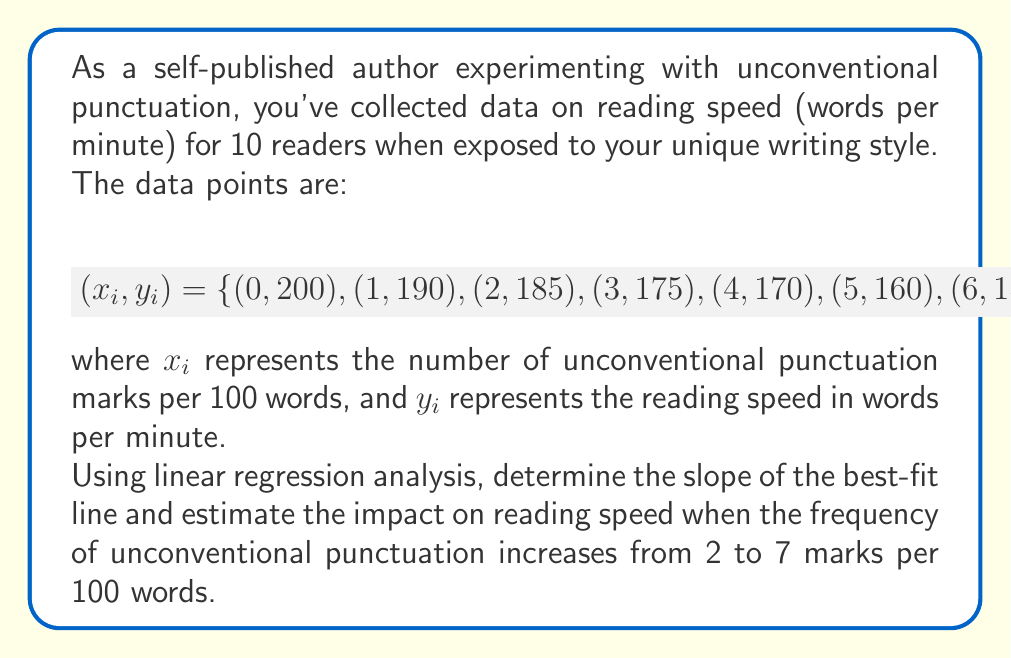Help me with this question. To solve this problem, we'll use linear regression analysis. The steps are as follows:

1) First, we need to calculate the slope of the best-fit line using the formula:

   $$m = \frac{n\sum_{i=1}^n x_iy_i - \sum_{i=1}^n x_i \sum_{i=1}^n y_i}{n\sum_{i=1}^n x_i^2 - (\sum_{i=1}^n x_i)^2}$$

2) Calculate the necessary sums:
   $n = 10$
   $\sum x_i = 0 + 1 + 2 + 3 + 4 + 5 + 6 + 7 + 8 + 9 = 45$
   $\sum y_i = 200 + 190 + 185 + 175 + 170 + 160 + 155 + 150 + 140 + 135 = 1660$
   $\sum x_i^2 = 0^2 + 1^2 + 2^2 + 3^2 + 4^2 + 5^2 + 6^2 + 7^2 + 8^2 + 9^2 = 285$
   $\sum x_iy_i = 0(200) + 1(190) + 2(185) + 3(175) + 4(170) + 5(160) + 6(155) + 7(150) + 8(140) + 9(135) = 6415$

3) Substitute these values into the slope formula:

   $$m = \frac{10(6415) - 45(1660)}{10(285) - 45^2} = \frac{64150 - 74700}{2850 - 2025} = \frac{-10550}{825} = -7.33333$$

4) The slope is approximately -7.33333, meaning that for each additional unconventional punctuation mark per 100 words, the reading speed decreases by about 7.33333 words per minute.

5) To estimate the impact when the frequency increases from 2 to 7 marks per 100 words, we multiply the change in x (5) by the slope:

   $$\text{Impact} = 5 \times (-7.33333) = -36.66667$$

This means the reading speed is estimated to decrease by approximately 36.67 words per minute when the frequency of unconventional punctuation increases from 2 to 7 marks per 100 words.
Answer: The slope of the best-fit line is approximately -7.33333 words per minute per unconventional punctuation mark. The estimated impact on reading speed when increasing from 2 to 7 unconventional punctuation marks per 100 words is a decrease of approximately 36.67 words per minute. 